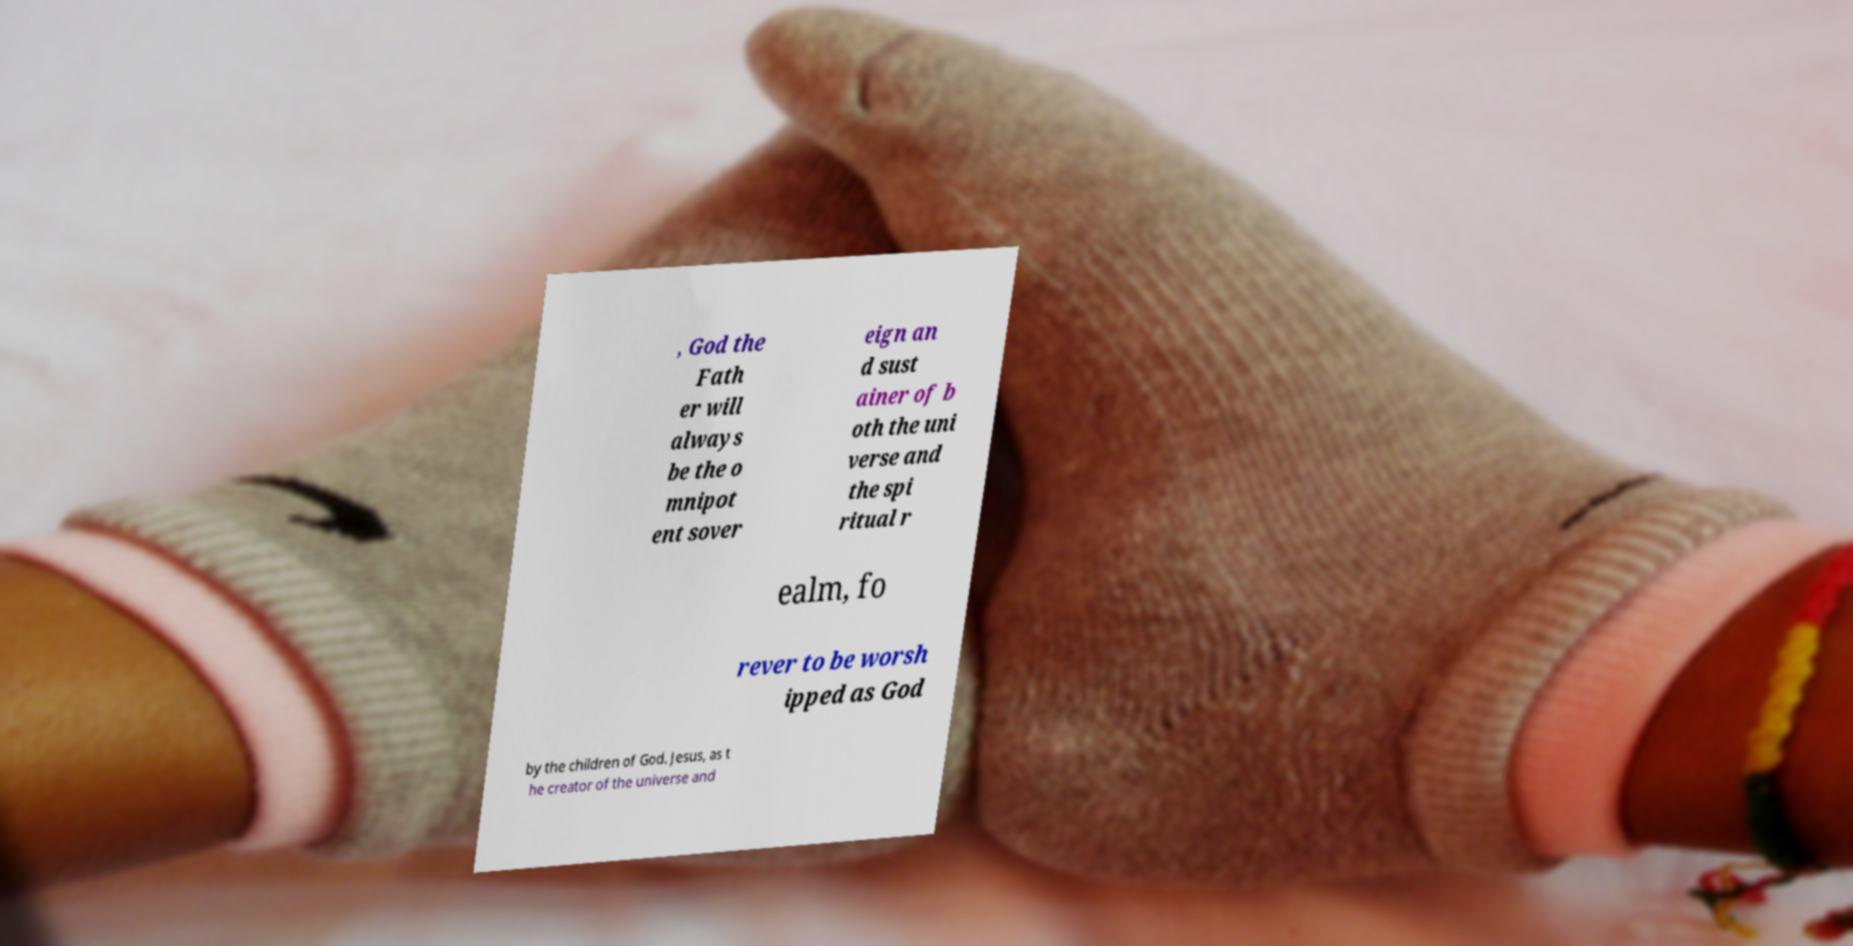There's text embedded in this image that I need extracted. Can you transcribe it verbatim? , God the Fath er will always be the o mnipot ent sover eign an d sust ainer of b oth the uni verse and the spi ritual r ealm, fo rever to be worsh ipped as God by the children of God. Jesus, as t he creator of the universe and 